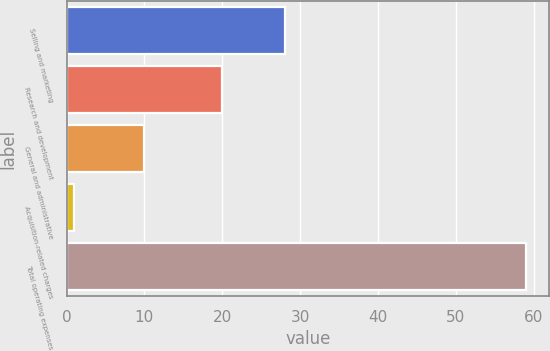Convert chart to OTSL. <chart><loc_0><loc_0><loc_500><loc_500><bar_chart><fcel>Selling and marketing<fcel>Research and development<fcel>General and administrative<fcel>Acquisition-related charges<fcel>Total operating expenses<nl><fcel>28<fcel>20<fcel>10<fcel>1<fcel>59<nl></chart> 